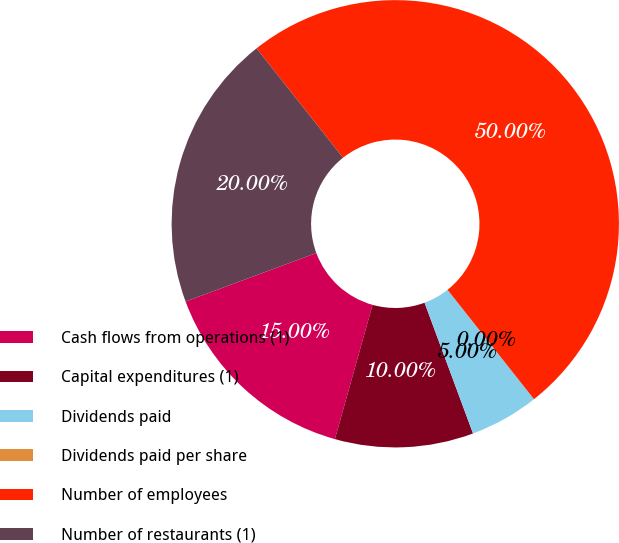Convert chart. <chart><loc_0><loc_0><loc_500><loc_500><pie_chart><fcel>Cash flows from operations (1)<fcel>Capital expenditures (1)<fcel>Dividends paid<fcel>Dividends paid per share<fcel>Number of employees<fcel>Number of restaurants (1)<nl><fcel>15.0%<fcel>10.0%<fcel>5.0%<fcel>0.0%<fcel>50.0%<fcel>20.0%<nl></chart> 